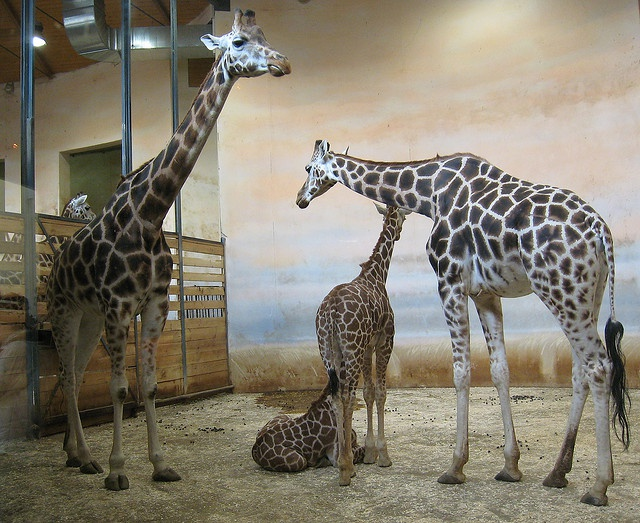Describe the objects in this image and their specific colors. I can see giraffe in black, gray, darkgray, and lightgray tones, giraffe in black and gray tones, giraffe in black and gray tones, giraffe in black and gray tones, and giraffe in black, gray, darkgreen, and darkgray tones in this image. 